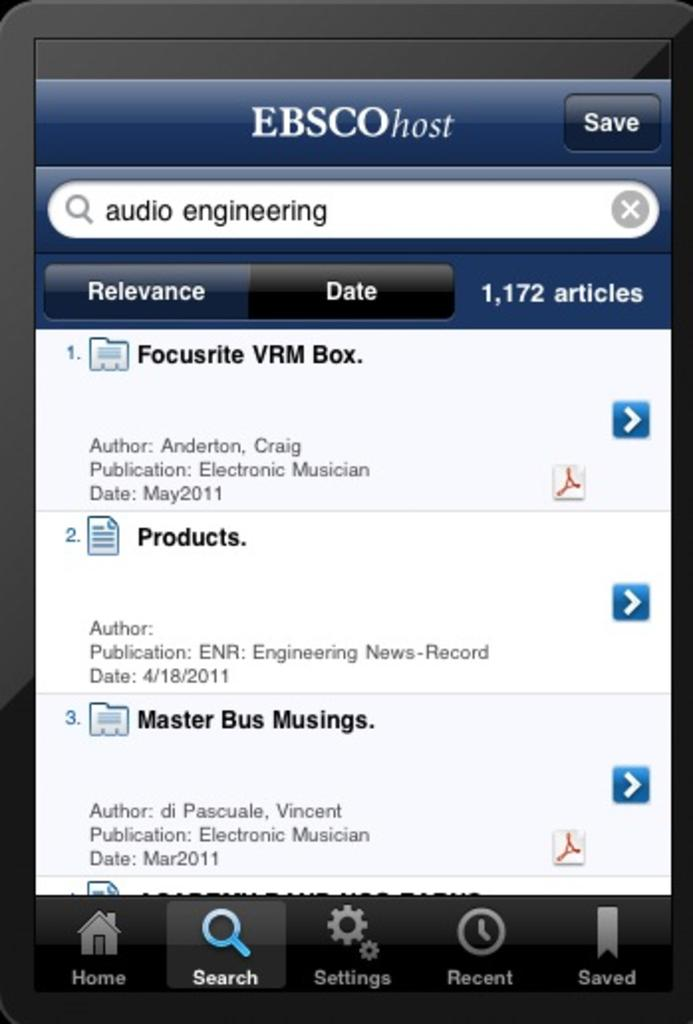Provide a one-sentence caption for the provided image. A web page containing an Ebsco host page on display. 